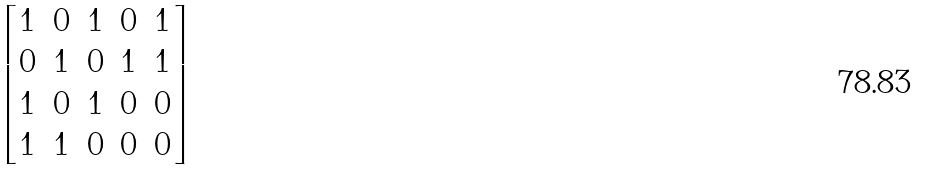Convert formula to latex. <formula><loc_0><loc_0><loc_500><loc_500>\begin{bmatrix} 1 & 0 & 1 & 0 & 1 \\ 0 & 1 & 0 & 1 & 1 \\ 1 & 0 & 1 & 0 & 0 \\ 1 & 1 & 0 & 0 & 0 \end{bmatrix}</formula> 